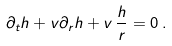Convert formula to latex. <formula><loc_0><loc_0><loc_500><loc_500>\partial _ { t } h + v \partial _ { r } h + v \, \frac { h } { r } = 0 \, .</formula> 